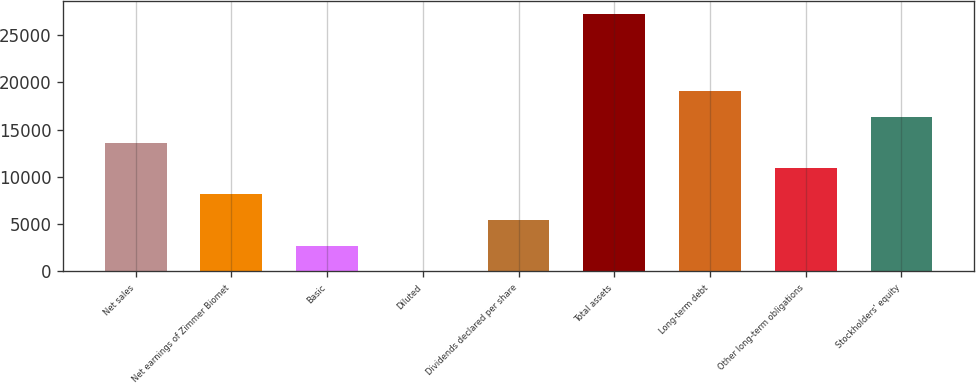Convert chart. <chart><loc_0><loc_0><loc_500><loc_500><bar_chart><fcel>Net sales<fcel>Net earnings of Zimmer Biomet<fcel>Basic<fcel>Diluted<fcel>Dividends declared per share<fcel>Total assets<fcel>Long-term debt<fcel>Other long-term obligations<fcel>Stockholders' equity<nl><fcel>13610.1<fcel>8166.38<fcel>2722.64<fcel>0.77<fcel>5444.51<fcel>27219.5<fcel>19053.9<fcel>10888.2<fcel>16332<nl></chart> 